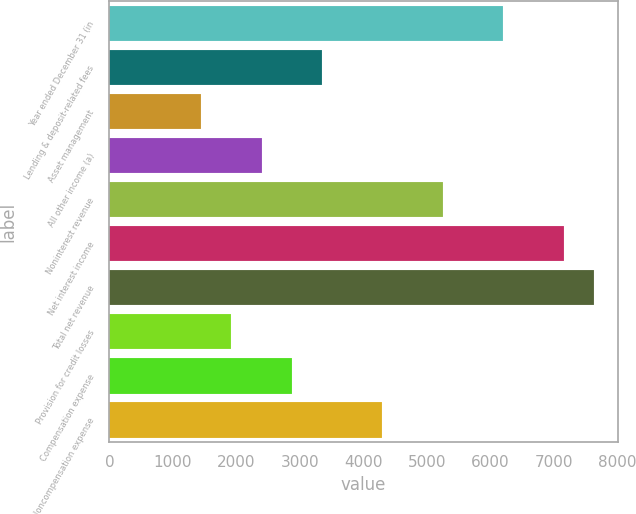Convert chart. <chart><loc_0><loc_0><loc_500><loc_500><bar_chart><fcel>Year ended December 31 (in<fcel>Lending & deposit-related fees<fcel>Asset management<fcel>All other income (a)<fcel>Noninterest revenue<fcel>Net interest income<fcel>Total net revenue<fcel>Provision for credit losses<fcel>Compensation expense<fcel>Noncompensation expense<nl><fcel>6204.1<fcel>3349.9<fcel>1447.1<fcel>2398.5<fcel>5252.7<fcel>7155.5<fcel>7631.2<fcel>1922.8<fcel>2874.2<fcel>4301.3<nl></chart> 